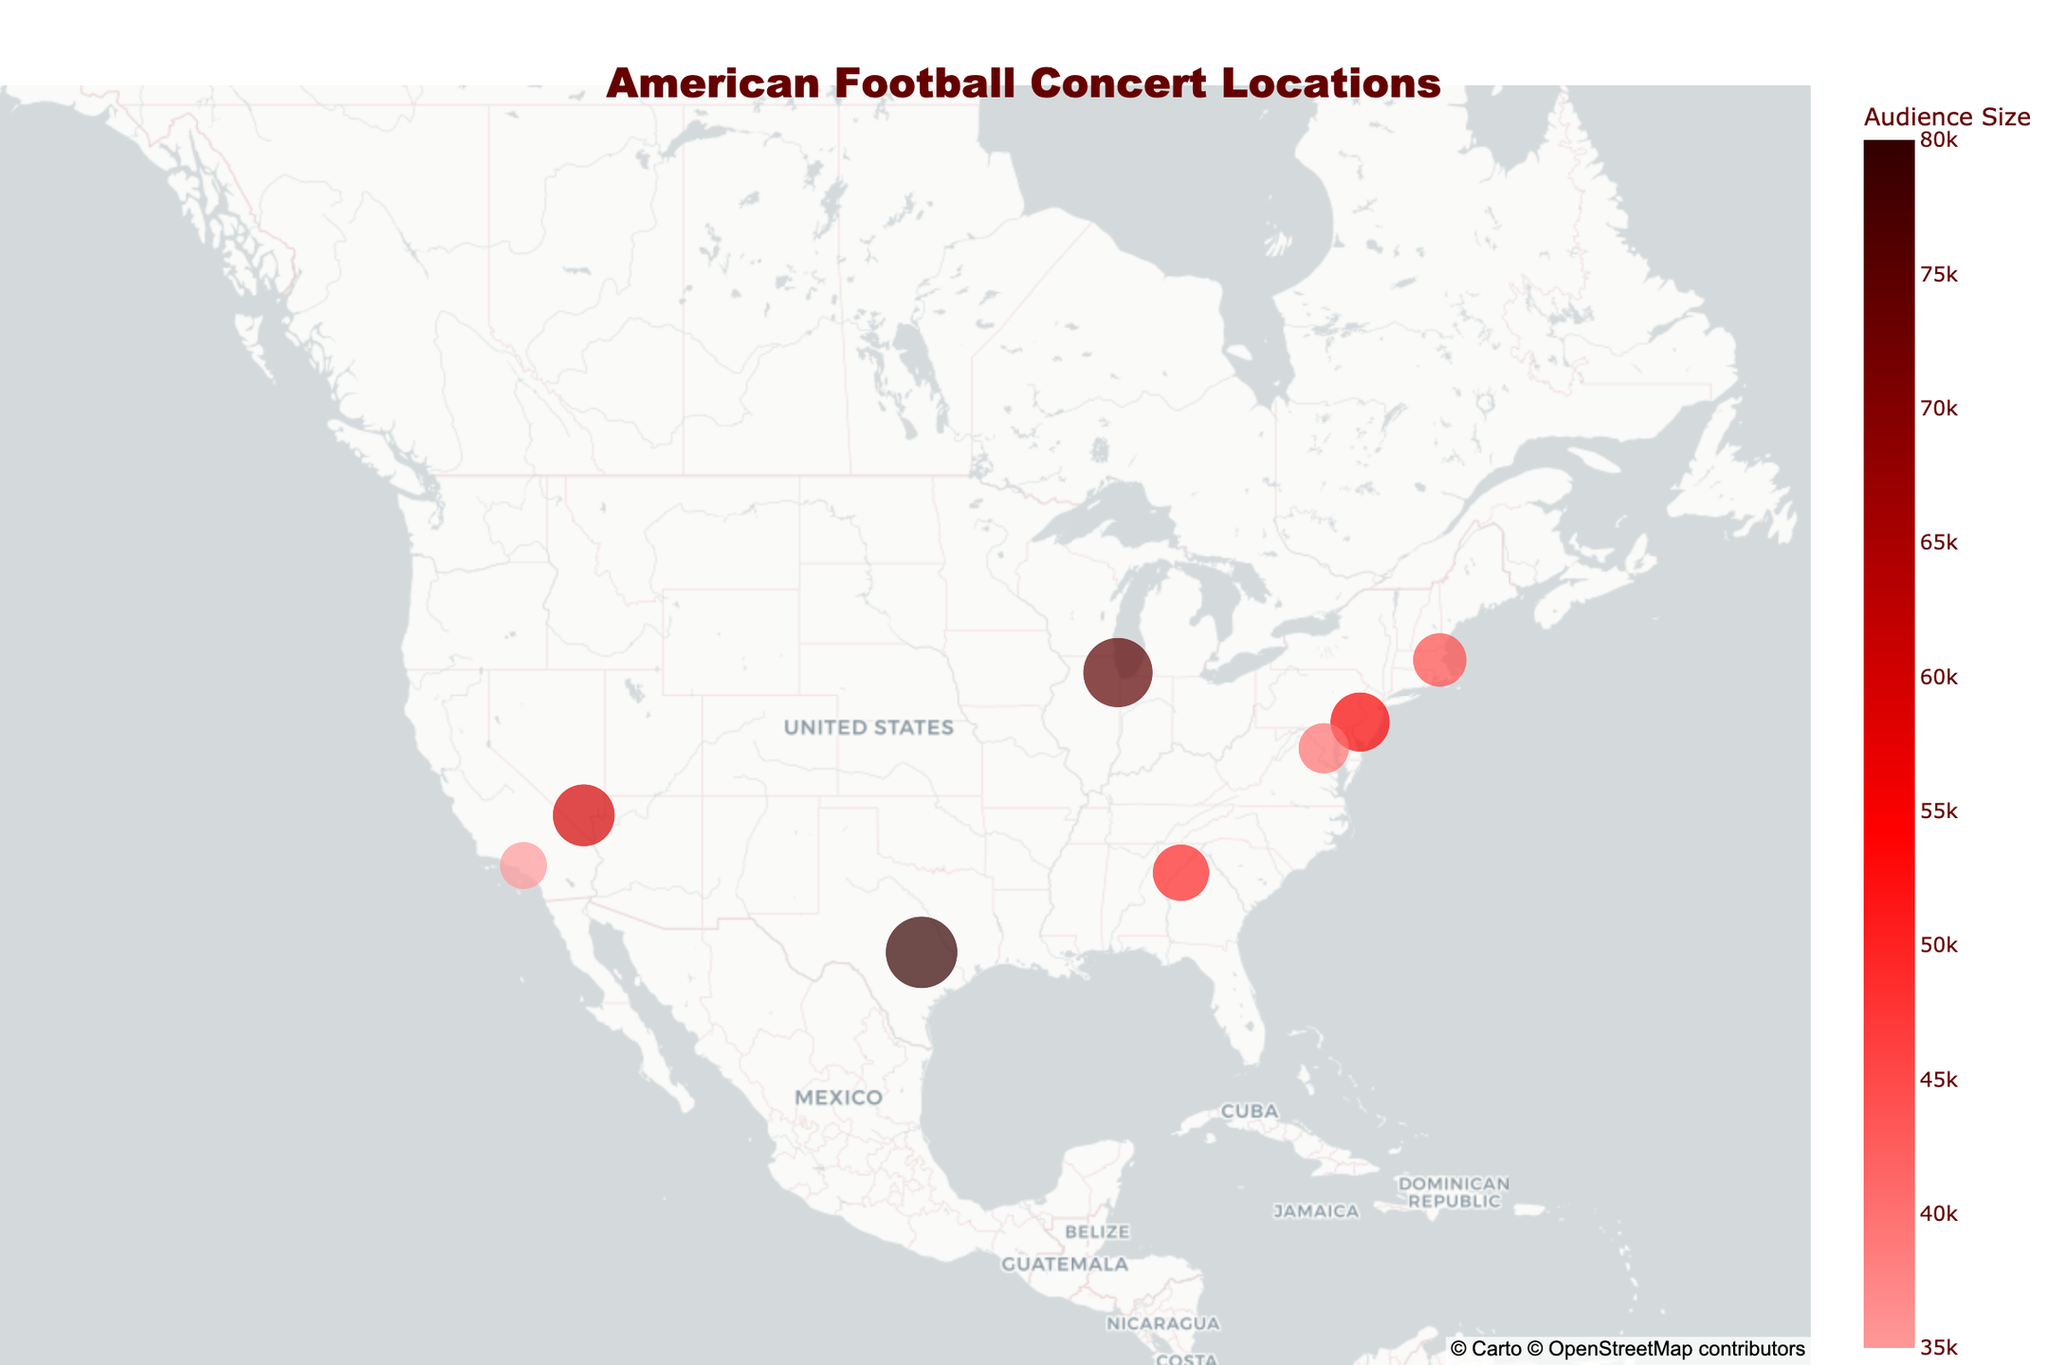Which city hosted the largest American Football concert? The largest concert can be identified by looking for the largest circle on the map, which is in Austin, TX, for the Austin City Limits concert with an audience size of 80,000.
Answer: Austin, TX How many concerts had an audience size greater than 50,000? Identify the circles with sizes greater than the mid-range on the map. The locations are Chicago, Austin, Atlanta, Las Vegas, and Philadelphia, totaling 5 concerts.
Answer: 5 Which concert had the smallest audience size? The smallest concert can be identified by looking for the smallest circle on the map, which is in Los Angeles, CA, for the Just Like Heaven concert with an audience size of 35,000.
Answer: Just Like Heaven in Los Angeles, CA What is the total audience size for all concerts combined? Add the audience sizes for all concerts: 75,000 (Chicago) + 50,000 (Atlanta) + 60,000 (Las Vegas) + 80,000 (Austin) + 55,000 (Philadelphia) + 40,000 (Washington, DC) + 35,000 (Los Angeles) + 45,000 (Boston) = 440,000.
Answer: 440,000 Which concert is the most recent one in the data? The most recent concert can be identified by the latest year on the map, which is the Boston Calling concert in Boston, MA in 2022.
Answer: Boston Calling in Boston, MA How many cities had concerts between 2010 and 2020? Identify the circles from the map data between the years 2010 and 2020. They are Atlanta (2013), Las Vegas (2015), Austin (2017), Philadelphia (2018), and Washington, DC (2019), totaling 5 cities.
Answer: 5 Between which two years is the largest difference in audience size observed? Compare the audience sizes between each consecutive pair of years. The largest difference is between 2017 (Austin, 80,000) and 2018 (Philadelphia, 55,000), a difference of 25,000.
Answer: Between 2017 and 2018 Which region of the US has the highest concentration of concert locations? Identify the region with the highest number of circles on the map. The East Coast has the highest concentration with concerts in Philadelphia, Washington, DC, and Boston.
Answer: The East Coast What is the average audience size of the concerts? Calculate the mean value: (75,000 + 50,000 + 60,000 + 80,000 + 55,000 + 40,000 + 35,000 + 45,000) / 8 = 55,000.
Answer: 55,000 